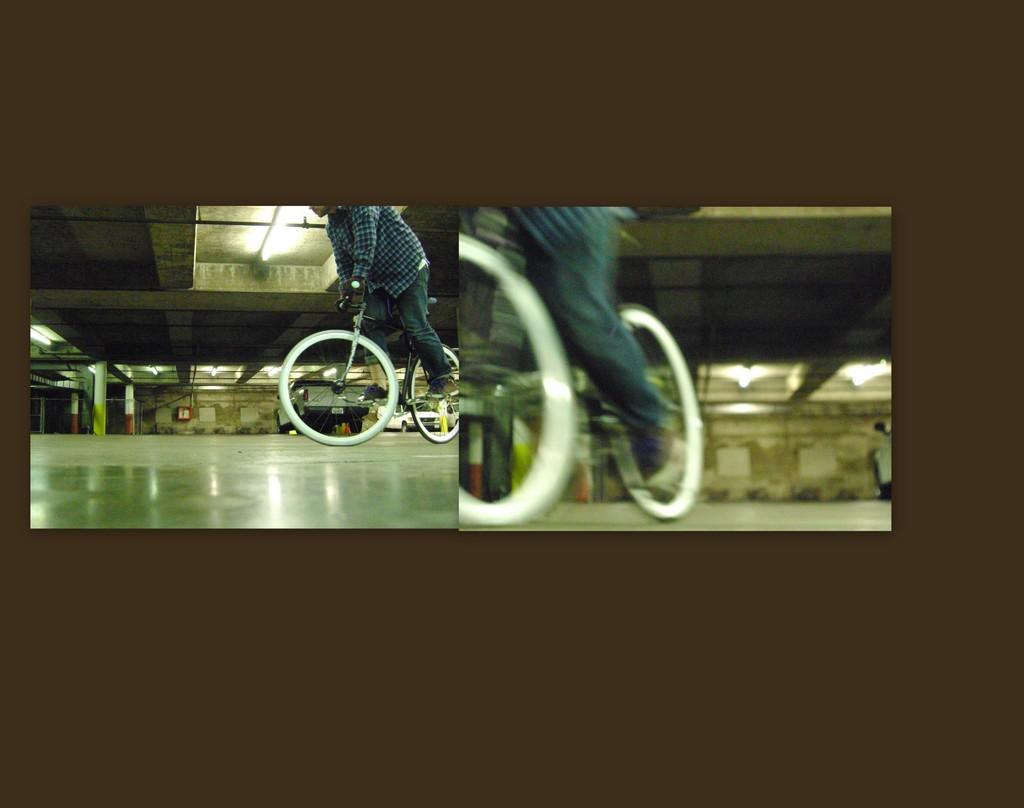Could you give a brief overview of what you see in this image? In this image we can see two collage pictures, in both the pictures there are walls, ceiling, lights, also we can see two persons are riding bicycles, in one picture there are vehicles, and pillars. 